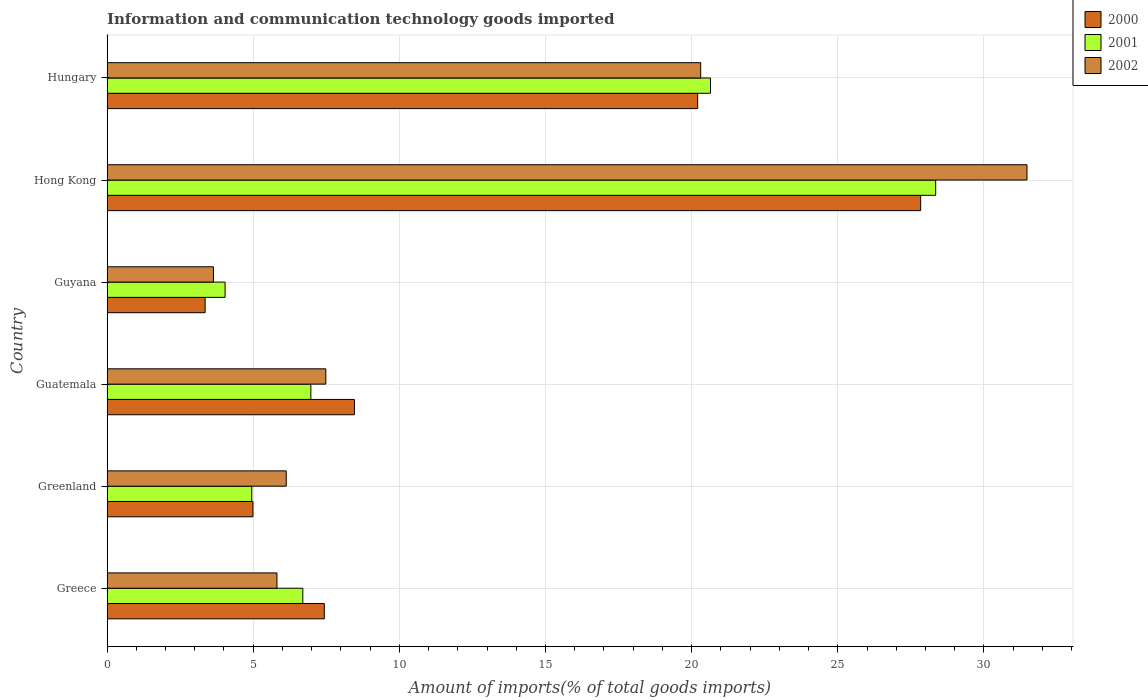How many different coloured bars are there?
Offer a terse response. 3. How many groups of bars are there?
Offer a terse response. 6. Are the number of bars per tick equal to the number of legend labels?
Make the answer very short. Yes. How many bars are there on the 4th tick from the top?
Offer a very short reply. 3. How many bars are there on the 2nd tick from the bottom?
Ensure brevity in your answer.  3. What is the label of the 2nd group of bars from the top?
Ensure brevity in your answer.  Hong Kong. What is the amount of goods imported in 2001 in Greenland?
Make the answer very short. 4.95. Across all countries, what is the maximum amount of goods imported in 2001?
Your answer should be very brief. 28.35. Across all countries, what is the minimum amount of goods imported in 2002?
Offer a terse response. 3.64. In which country was the amount of goods imported in 2001 maximum?
Offer a terse response. Hong Kong. In which country was the amount of goods imported in 2002 minimum?
Your response must be concise. Guyana. What is the total amount of goods imported in 2001 in the graph?
Your answer should be compact. 71.66. What is the difference between the amount of goods imported in 2001 in Greenland and that in Guyana?
Give a very brief answer. 0.91. What is the difference between the amount of goods imported in 2001 in Guyana and the amount of goods imported in 2002 in Greenland?
Your response must be concise. -2.09. What is the average amount of goods imported in 2000 per country?
Give a very brief answer. 12.05. What is the difference between the amount of goods imported in 2000 and amount of goods imported in 2001 in Greenland?
Make the answer very short. 0.04. What is the ratio of the amount of goods imported in 2002 in Guatemala to that in Hong Kong?
Keep it short and to the point. 0.24. Is the amount of goods imported in 2000 in Greenland less than that in Guyana?
Give a very brief answer. No. Is the difference between the amount of goods imported in 2000 in Guatemala and Hong Kong greater than the difference between the amount of goods imported in 2001 in Guatemala and Hong Kong?
Offer a very short reply. Yes. What is the difference between the highest and the second highest amount of goods imported in 2000?
Offer a terse response. 7.63. What is the difference between the highest and the lowest amount of goods imported in 2002?
Your response must be concise. 27.83. In how many countries, is the amount of goods imported in 2002 greater than the average amount of goods imported in 2002 taken over all countries?
Your answer should be compact. 2. How many countries are there in the graph?
Give a very brief answer. 6. What is the difference between two consecutive major ticks on the X-axis?
Your response must be concise. 5. Are the values on the major ticks of X-axis written in scientific E-notation?
Offer a very short reply. No. Does the graph contain grids?
Provide a short and direct response. Yes. Where does the legend appear in the graph?
Give a very brief answer. Top right. How many legend labels are there?
Keep it short and to the point. 3. How are the legend labels stacked?
Your response must be concise. Vertical. What is the title of the graph?
Your answer should be very brief. Information and communication technology goods imported. What is the label or title of the X-axis?
Offer a very short reply. Amount of imports(% of total goods imports). What is the label or title of the Y-axis?
Offer a terse response. Country. What is the Amount of imports(% of total goods imports) in 2000 in Greece?
Offer a very short reply. 7.43. What is the Amount of imports(% of total goods imports) of 2001 in Greece?
Offer a terse response. 6.7. What is the Amount of imports(% of total goods imports) in 2002 in Greece?
Provide a succinct answer. 5.81. What is the Amount of imports(% of total goods imports) of 2000 in Greenland?
Your answer should be very brief. 4.99. What is the Amount of imports(% of total goods imports) in 2001 in Greenland?
Provide a succinct answer. 4.95. What is the Amount of imports(% of total goods imports) in 2002 in Greenland?
Your answer should be compact. 6.13. What is the Amount of imports(% of total goods imports) of 2000 in Guatemala?
Offer a terse response. 8.46. What is the Amount of imports(% of total goods imports) of 2001 in Guatemala?
Your answer should be very brief. 6.97. What is the Amount of imports(% of total goods imports) of 2002 in Guatemala?
Keep it short and to the point. 7.49. What is the Amount of imports(% of total goods imports) in 2000 in Guyana?
Your response must be concise. 3.36. What is the Amount of imports(% of total goods imports) in 2001 in Guyana?
Make the answer very short. 4.04. What is the Amount of imports(% of total goods imports) in 2002 in Guyana?
Give a very brief answer. 3.64. What is the Amount of imports(% of total goods imports) of 2000 in Hong Kong?
Give a very brief answer. 27.84. What is the Amount of imports(% of total goods imports) in 2001 in Hong Kong?
Your answer should be compact. 28.35. What is the Amount of imports(% of total goods imports) of 2002 in Hong Kong?
Your answer should be compact. 31.47. What is the Amount of imports(% of total goods imports) of 2000 in Hungary?
Keep it short and to the point. 20.21. What is the Amount of imports(% of total goods imports) in 2001 in Hungary?
Offer a very short reply. 20.65. What is the Amount of imports(% of total goods imports) in 2002 in Hungary?
Offer a very short reply. 20.31. Across all countries, what is the maximum Amount of imports(% of total goods imports) in 2000?
Ensure brevity in your answer.  27.84. Across all countries, what is the maximum Amount of imports(% of total goods imports) of 2001?
Offer a terse response. 28.35. Across all countries, what is the maximum Amount of imports(% of total goods imports) in 2002?
Provide a short and direct response. 31.47. Across all countries, what is the minimum Amount of imports(% of total goods imports) of 2000?
Provide a succinct answer. 3.36. Across all countries, what is the minimum Amount of imports(% of total goods imports) of 2001?
Offer a terse response. 4.04. Across all countries, what is the minimum Amount of imports(% of total goods imports) of 2002?
Provide a succinct answer. 3.64. What is the total Amount of imports(% of total goods imports) of 2000 in the graph?
Provide a succinct answer. 72.29. What is the total Amount of imports(% of total goods imports) of 2001 in the graph?
Offer a terse response. 71.66. What is the total Amount of imports(% of total goods imports) of 2002 in the graph?
Your response must be concise. 74.85. What is the difference between the Amount of imports(% of total goods imports) of 2000 in Greece and that in Greenland?
Offer a very short reply. 2.44. What is the difference between the Amount of imports(% of total goods imports) of 2001 in Greece and that in Greenland?
Keep it short and to the point. 1.75. What is the difference between the Amount of imports(% of total goods imports) of 2002 in Greece and that in Greenland?
Provide a short and direct response. -0.32. What is the difference between the Amount of imports(% of total goods imports) of 2000 in Greece and that in Guatemala?
Your answer should be very brief. -1.03. What is the difference between the Amount of imports(% of total goods imports) of 2001 in Greece and that in Guatemala?
Your response must be concise. -0.28. What is the difference between the Amount of imports(% of total goods imports) of 2002 in Greece and that in Guatemala?
Ensure brevity in your answer.  -1.67. What is the difference between the Amount of imports(% of total goods imports) of 2000 in Greece and that in Guyana?
Ensure brevity in your answer.  4.08. What is the difference between the Amount of imports(% of total goods imports) in 2001 in Greece and that in Guyana?
Offer a terse response. 2.66. What is the difference between the Amount of imports(% of total goods imports) in 2002 in Greece and that in Guyana?
Give a very brief answer. 2.17. What is the difference between the Amount of imports(% of total goods imports) in 2000 in Greece and that in Hong Kong?
Offer a very short reply. -20.4. What is the difference between the Amount of imports(% of total goods imports) of 2001 in Greece and that in Hong Kong?
Your answer should be very brief. -21.65. What is the difference between the Amount of imports(% of total goods imports) of 2002 in Greece and that in Hong Kong?
Provide a short and direct response. -25.66. What is the difference between the Amount of imports(% of total goods imports) of 2000 in Greece and that in Hungary?
Your answer should be very brief. -12.77. What is the difference between the Amount of imports(% of total goods imports) of 2001 in Greece and that in Hungary?
Keep it short and to the point. -13.95. What is the difference between the Amount of imports(% of total goods imports) of 2002 in Greece and that in Hungary?
Provide a succinct answer. -14.5. What is the difference between the Amount of imports(% of total goods imports) in 2000 in Greenland and that in Guatemala?
Provide a succinct answer. -3.47. What is the difference between the Amount of imports(% of total goods imports) in 2001 in Greenland and that in Guatemala?
Provide a short and direct response. -2.02. What is the difference between the Amount of imports(% of total goods imports) in 2002 in Greenland and that in Guatemala?
Ensure brevity in your answer.  -1.35. What is the difference between the Amount of imports(% of total goods imports) of 2000 in Greenland and that in Guyana?
Keep it short and to the point. 1.64. What is the difference between the Amount of imports(% of total goods imports) of 2001 in Greenland and that in Guyana?
Make the answer very short. 0.91. What is the difference between the Amount of imports(% of total goods imports) in 2002 in Greenland and that in Guyana?
Your answer should be very brief. 2.49. What is the difference between the Amount of imports(% of total goods imports) of 2000 in Greenland and that in Hong Kong?
Offer a terse response. -22.84. What is the difference between the Amount of imports(% of total goods imports) in 2001 in Greenland and that in Hong Kong?
Offer a terse response. -23.4. What is the difference between the Amount of imports(% of total goods imports) of 2002 in Greenland and that in Hong Kong?
Make the answer very short. -25.34. What is the difference between the Amount of imports(% of total goods imports) in 2000 in Greenland and that in Hungary?
Provide a succinct answer. -15.21. What is the difference between the Amount of imports(% of total goods imports) in 2001 in Greenland and that in Hungary?
Provide a short and direct response. -15.69. What is the difference between the Amount of imports(% of total goods imports) in 2002 in Greenland and that in Hungary?
Offer a terse response. -14.18. What is the difference between the Amount of imports(% of total goods imports) in 2000 in Guatemala and that in Guyana?
Your answer should be very brief. 5.11. What is the difference between the Amount of imports(% of total goods imports) of 2001 in Guatemala and that in Guyana?
Offer a terse response. 2.93. What is the difference between the Amount of imports(% of total goods imports) in 2002 in Guatemala and that in Guyana?
Your answer should be compact. 3.84. What is the difference between the Amount of imports(% of total goods imports) in 2000 in Guatemala and that in Hong Kong?
Provide a succinct answer. -19.37. What is the difference between the Amount of imports(% of total goods imports) in 2001 in Guatemala and that in Hong Kong?
Keep it short and to the point. -21.37. What is the difference between the Amount of imports(% of total goods imports) in 2002 in Guatemala and that in Hong Kong?
Your answer should be very brief. -23.99. What is the difference between the Amount of imports(% of total goods imports) in 2000 in Guatemala and that in Hungary?
Your response must be concise. -11.74. What is the difference between the Amount of imports(% of total goods imports) of 2001 in Guatemala and that in Hungary?
Give a very brief answer. -13.67. What is the difference between the Amount of imports(% of total goods imports) in 2002 in Guatemala and that in Hungary?
Your answer should be very brief. -12.82. What is the difference between the Amount of imports(% of total goods imports) in 2000 in Guyana and that in Hong Kong?
Give a very brief answer. -24.48. What is the difference between the Amount of imports(% of total goods imports) in 2001 in Guyana and that in Hong Kong?
Make the answer very short. -24.31. What is the difference between the Amount of imports(% of total goods imports) of 2002 in Guyana and that in Hong Kong?
Provide a succinct answer. -27.83. What is the difference between the Amount of imports(% of total goods imports) of 2000 in Guyana and that in Hungary?
Your answer should be very brief. -16.85. What is the difference between the Amount of imports(% of total goods imports) in 2001 in Guyana and that in Hungary?
Provide a short and direct response. -16.61. What is the difference between the Amount of imports(% of total goods imports) of 2002 in Guyana and that in Hungary?
Keep it short and to the point. -16.67. What is the difference between the Amount of imports(% of total goods imports) of 2000 in Hong Kong and that in Hungary?
Ensure brevity in your answer.  7.63. What is the difference between the Amount of imports(% of total goods imports) of 2001 in Hong Kong and that in Hungary?
Your answer should be compact. 7.7. What is the difference between the Amount of imports(% of total goods imports) of 2002 in Hong Kong and that in Hungary?
Provide a succinct answer. 11.16. What is the difference between the Amount of imports(% of total goods imports) in 2000 in Greece and the Amount of imports(% of total goods imports) in 2001 in Greenland?
Provide a succinct answer. 2.48. What is the difference between the Amount of imports(% of total goods imports) of 2000 in Greece and the Amount of imports(% of total goods imports) of 2002 in Greenland?
Keep it short and to the point. 1.3. What is the difference between the Amount of imports(% of total goods imports) of 2001 in Greece and the Amount of imports(% of total goods imports) of 2002 in Greenland?
Your response must be concise. 0.57. What is the difference between the Amount of imports(% of total goods imports) of 2000 in Greece and the Amount of imports(% of total goods imports) of 2001 in Guatemala?
Keep it short and to the point. 0.46. What is the difference between the Amount of imports(% of total goods imports) in 2000 in Greece and the Amount of imports(% of total goods imports) in 2002 in Guatemala?
Keep it short and to the point. -0.05. What is the difference between the Amount of imports(% of total goods imports) of 2001 in Greece and the Amount of imports(% of total goods imports) of 2002 in Guatemala?
Provide a short and direct response. -0.79. What is the difference between the Amount of imports(% of total goods imports) in 2000 in Greece and the Amount of imports(% of total goods imports) in 2001 in Guyana?
Provide a short and direct response. 3.39. What is the difference between the Amount of imports(% of total goods imports) of 2000 in Greece and the Amount of imports(% of total goods imports) of 2002 in Guyana?
Provide a succinct answer. 3.79. What is the difference between the Amount of imports(% of total goods imports) in 2001 in Greece and the Amount of imports(% of total goods imports) in 2002 in Guyana?
Ensure brevity in your answer.  3.06. What is the difference between the Amount of imports(% of total goods imports) of 2000 in Greece and the Amount of imports(% of total goods imports) of 2001 in Hong Kong?
Provide a short and direct response. -20.91. What is the difference between the Amount of imports(% of total goods imports) of 2000 in Greece and the Amount of imports(% of total goods imports) of 2002 in Hong Kong?
Give a very brief answer. -24.04. What is the difference between the Amount of imports(% of total goods imports) in 2001 in Greece and the Amount of imports(% of total goods imports) in 2002 in Hong Kong?
Your response must be concise. -24.77. What is the difference between the Amount of imports(% of total goods imports) of 2000 in Greece and the Amount of imports(% of total goods imports) of 2001 in Hungary?
Your response must be concise. -13.21. What is the difference between the Amount of imports(% of total goods imports) in 2000 in Greece and the Amount of imports(% of total goods imports) in 2002 in Hungary?
Provide a succinct answer. -12.88. What is the difference between the Amount of imports(% of total goods imports) in 2001 in Greece and the Amount of imports(% of total goods imports) in 2002 in Hungary?
Your answer should be very brief. -13.61. What is the difference between the Amount of imports(% of total goods imports) in 2000 in Greenland and the Amount of imports(% of total goods imports) in 2001 in Guatemala?
Provide a succinct answer. -1.98. What is the difference between the Amount of imports(% of total goods imports) in 2000 in Greenland and the Amount of imports(% of total goods imports) in 2002 in Guatemala?
Provide a short and direct response. -2.49. What is the difference between the Amount of imports(% of total goods imports) of 2001 in Greenland and the Amount of imports(% of total goods imports) of 2002 in Guatemala?
Your response must be concise. -2.53. What is the difference between the Amount of imports(% of total goods imports) in 2000 in Greenland and the Amount of imports(% of total goods imports) in 2001 in Guyana?
Provide a succinct answer. 0.95. What is the difference between the Amount of imports(% of total goods imports) of 2000 in Greenland and the Amount of imports(% of total goods imports) of 2002 in Guyana?
Your response must be concise. 1.35. What is the difference between the Amount of imports(% of total goods imports) of 2001 in Greenland and the Amount of imports(% of total goods imports) of 2002 in Guyana?
Your response must be concise. 1.31. What is the difference between the Amount of imports(% of total goods imports) in 2000 in Greenland and the Amount of imports(% of total goods imports) in 2001 in Hong Kong?
Your response must be concise. -23.36. What is the difference between the Amount of imports(% of total goods imports) in 2000 in Greenland and the Amount of imports(% of total goods imports) in 2002 in Hong Kong?
Your answer should be compact. -26.48. What is the difference between the Amount of imports(% of total goods imports) of 2001 in Greenland and the Amount of imports(% of total goods imports) of 2002 in Hong Kong?
Ensure brevity in your answer.  -26.52. What is the difference between the Amount of imports(% of total goods imports) in 2000 in Greenland and the Amount of imports(% of total goods imports) in 2001 in Hungary?
Make the answer very short. -15.65. What is the difference between the Amount of imports(% of total goods imports) in 2000 in Greenland and the Amount of imports(% of total goods imports) in 2002 in Hungary?
Your response must be concise. -15.32. What is the difference between the Amount of imports(% of total goods imports) of 2001 in Greenland and the Amount of imports(% of total goods imports) of 2002 in Hungary?
Your response must be concise. -15.36. What is the difference between the Amount of imports(% of total goods imports) of 2000 in Guatemala and the Amount of imports(% of total goods imports) of 2001 in Guyana?
Give a very brief answer. 4.42. What is the difference between the Amount of imports(% of total goods imports) in 2000 in Guatemala and the Amount of imports(% of total goods imports) in 2002 in Guyana?
Ensure brevity in your answer.  4.82. What is the difference between the Amount of imports(% of total goods imports) in 2001 in Guatemala and the Amount of imports(% of total goods imports) in 2002 in Guyana?
Ensure brevity in your answer.  3.33. What is the difference between the Amount of imports(% of total goods imports) in 2000 in Guatemala and the Amount of imports(% of total goods imports) in 2001 in Hong Kong?
Offer a terse response. -19.88. What is the difference between the Amount of imports(% of total goods imports) in 2000 in Guatemala and the Amount of imports(% of total goods imports) in 2002 in Hong Kong?
Give a very brief answer. -23.01. What is the difference between the Amount of imports(% of total goods imports) of 2001 in Guatemala and the Amount of imports(% of total goods imports) of 2002 in Hong Kong?
Ensure brevity in your answer.  -24.5. What is the difference between the Amount of imports(% of total goods imports) in 2000 in Guatemala and the Amount of imports(% of total goods imports) in 2001 in Hungary?
Give a very brief answer. -12.18. What is the difference between the Amount of imports(% of total goods imports) in 2000 in Guatemala and the Amount of imports(% of total goods imports) in 2002 in Hungary?
Ensure brevity in your answer.  -11.85. What is the difference between the Amount of imports(% of total goods imports) of 2001 in Guatemala and the Amount of imports(% of total goods imports) of 2002 in Hungary?
Offer a very short reply. -13.34. What is the difference between the Amount of imports(% of total goods imports) in 2000 in Guyana and the Amount of imports(% of total goods imports) in 2001 in Hong Kong?
Give a very brief answer. -24.99. What is the difference between the Amount of imports(% of total goods imports) in 2000 in Guyana and the Amount of imports(% of total goods imports) in 2002 in Hong Kong?
Give a very brief answer. -28.12. What is the difference between the Amount of imports(% of total goods imports) in 2001 in Guyana and the Amount of imports(% of total goods imports) in 2002 in Hong Kong?
Your answer should be compact. -27.43. What is the difference between the Amount of imports(% of total goods imports) of 2000 in Guyana and the Amount of imports(% of total goods imports) of 2001 in Hungary?
Make the answer very short. -17.29. What is the difference between the Amount of imports(% of total goods imports) of 2000 in Guyana and the Amount of imports(% of total goods imports) of 2002 in Hungary?
Offer a very short reply. -16.95. What is the difference between the Amount of imports(% of total goods imports) in 2001 in Guyana and the Amount of imports(% of total goods imports) in 2002 in Hungary?
Offer a very short reply. -16.27. What is the difference between the Amount of imports(% of total goods imports) of 2000 in Hong Kong and the Amount of imports(% of total goods imports) of 2001 in Hungary?
Keep it short and to the point. 7.19. What is the difference between the Amount of imports(% of total goods imports) of 2000 in Hong Kong and the Amount of imports(% of total goods imports) of 2002 in Hungary?
Provide a succinct answer. 7.53. What is the difference between the Amount of imports(% of total goods imports) in 2001 in Hong Kong and the Amount of imports(% of total goods imports) in 2002 in Hungary?
Provide a succinct answer. 8.04. What is the average Amount of imports(% of total goods imports) of 2000 per country?
Offer a very short reply. 12.05. What is the average Amount of imports(% of total goods imports) in 2001 per country?
Your response must be concise. 11.94. What is the average Amount of imports(% of total goods imports) in 2002 per country?
Your response must be concise. 12.48. What is the difference between the Amount of imports(% of total goods imports) of 2000 and Amount of imports(% of total goods imports) of 2001 in Greece?
Provide a short and direct response. 0.74. What is the difference between the Amount of imports(% of total goods imports) in 2000 and Amount of imports(% of total goods imports) in 2002 in Greece?
Keep it short and to the point. 1.62. What is the difference between the Amount of imports(% of total goods imports) in 2001 and Amount of imports(% of total goods imports) in 2002 in Greece?
Provide a short and direct response. 0.88. What is the difference between the Amount of imports(% of total goods imports) in 2000 and Amount of imports(% of total goods imports) in 2001 in Greenland?
Provide a short and direct response. 0.04. What is the difference between the Amount of imports(% of total goods imports) in 2000 and Amount of imports(% of total goods imports) in 2002 in Greenland?
Your response must be concise. -1.14. What is the difference between the Amount of imports(% of total goods imports) of 2001 and Amount of imports(% of total goods imports) of 2002 in Greenland?
Ensure brevity in your answer.  -1.18. What is the difference between the Amount of imports(% of total goods imports) of 2000 and Amount of imports(% of total goods imports) of 2001 in Guatemala?
Offer a very short reply. 1.49. What is the difference between the Amount of imports(% of total goods imports) of 2000 and Amount of imports(% of total goods imports) of 2002 in Guatemala?
Give a very brief answer. 0.98. What is the difference between the Amount of imports(% of total goods imports) of 2001 and Amount of imports(% of total goods imports) of 2002 in Guatemala?
Your answer should be very brief. -0.51. What is the difference between the Amount of imports(% of total goods imports) of 2000 and Amount of imports(% of total goods imports) of 2001 in Guyana?
Your answer should be compact. -0.68. What is the difference between the Amount of imports(% of total goods imports) in 2000 and Amount of imports(% of total goods imports) in 2002 in Guyana?
Provide a short and direct response. -0.28. What is the difference between the Amount of imports(% of total goods imports) of 2001 and Amount of imports(% of total goods imports) of 2002 in Guyana?
Provide a succinct answer. 0.4. What is the difference between the Amount of imports(% of total goods imports) of 2000 and Amount of imports(% of total goods imports) of 2001 in Hong Kong?
Offer a very short reply. -0.51. What is the difference between the Amount of imports(% of total goods imports) of 2000 and Amount of imports(% of total goods imports) of 2002 in Hong Kong?
Offer a terse response. -3.64. What is the difference between the Amount of imports(% of total goods imports) in 2001 and Amount of imports(% of total goods imports) in 2002 in Hong Kong?
Provide a short and direct response. -3.12. What is the difference between the Amount of imports(% of total goods imports) in 2000 and Amount of imports(% of total goods imports) in 2001 in Hungary?
Give a very brief answer. -0.44. What is the difference between the Amount of imports(% of total goods imports) in 2000 and Amount of imports(% of total goods imports) in 2002 in Hungary?
Ensure brevity in your answer.  -0.1. What is the difference between the Amount of imports(% of total goods imports) in 2001 and Amount of imports(% of total goods imports) in 2002 in Hungary?
Provide a short and direct response. 0.34. What is the ratio of the Amount of imports(% of total goods imports) in 2000 in Greece to that in Greenland?
Offer a very short reply. 1.49. What is the ratio of the Amount of imports(% of total goods imports) in 2001 in Greece to that in Greenland?
Keep it short and to the point. 1.35. What is the ratio of the Amount of imports(% of total goods imports) of 2002 in Greece to that in Greenland?
Make the answer very short. 0.95. What is the ratio of the Amount of imports(% of total goods imports) in 2000 in Greece to that in Guatemala?
Offer a terse response. 0.88. What is the ratio of the Amount of imports(% of total goods imports) in 2001 in Greece to that in Guatemala?
Keep it short and to the point. 0.96. What is the ratio of the Amount of imports(% of total goods imports) in 2002 in Greece to that in Guatemala?
Provide a succinct answer. 0.78. What is the ratio of the Amount of imports(% of total goods imports) of 2000 in Greece to that in Guyana?
Ensure brevity in your answer.  2.21. What is the ratio of the Amount of imports(% of total goods imports) in 2001 in Greece to that in Guyana?
Your answer should be compact. 1.66. What is the ratio of the Amount of imports(% of total goods imports) in 2002 in Greece to that in Guyana?
Offer a very short reply. 1.6. What is the ratio of the Amount of imports(% of total goods imports) in 2000 in Greece to that in Hong Kong?
Keep it short and to the point. 0.27. What is the ratio of the Amount of imports(% of total goods imports) in 2001 in Greece to that in Hong Kong?
Give a very brief answer. 0.24. What is the ratio of the Amount of imports(% of total goods imports) in 2002 in Greece to that in Hong Kong?
Offer a very short reply. 0.18. What is the ratio of the Amount of imports(% of total goods imports) in 2000 in Greece to that in Hungary?
Your answer should be very brief. 0.37. What is the ratio of the Amount of imports(% of total goods imports) of 2001 in Greece to that in Hungary?
Your answer should be very brief. 0.32. What is the ratio of the Amount of imports(% of total goods imports) of 2002 in Greece to that in Hungary?
Keep it short and to the point. 0.29. What is the ratio of the Amount of imports(% of total goods imports) of 2000 in Greenland to that in Guatemala?
Your answer should be compact. 0.59. What is the ratio of the Amount of imports(% of total goods imports) of 2001 in Greenland to that in Guatemala?
Provide a short and direct response. 0.71. What is the ratio of the Amount of imports(% of total goods imports) in 2002 in Greenland to that in Guatemala?
Offer a very short reply. 0.82. What is the ratio of the Amount of imports(% of total goods imports) of 2000 in Greenland to that in Guyana?
Give a very brief answer. 1.49. What is the ratio of the Amount of imports(% of total goods imports) in 2001 in Greenland to that in Guyana?
Your answer should be compact. 1.23. What is the ratio of the Amount of imports(% of total goods imports) in 2002 in Greenland to that in Guyana?
Offer a very short reply. 1.68. What is the ratio of the Amount of imports(% of total goods imports) of 2000 in Greenland to that in Hong Kong?
Offer a very short reply. 0.18. What is the ratio of the Amount of imports(% of total goods imports) in 2001 in Greenland to that in Hong Kong?
Offer a terse response. 0.17. What is the ratio of the Amount of imports(% of total goods imports) of 2002 in Greenland to that in Hong Kong?
Offer a very short reply. 0.19. What is the ratio of the Amount of imports(% of total goods imports) in 2000 in Greenland to that in Hungary?
Your response must be concise. 0.25. What is the ratio of the Amount of imports(% of total goods imports) of 2001 in Greenland to that in Hungary?
Your response must be concise. 0.24. What is the ratio of the Amount of imports(% of total goods imports) of 2002 in Greenland to that in Hungary?
Your answer should be very brief. 0.3. What is the ratio of the Amount of imports(% of total goods imports) of 2000 in Guatemala to that in Guyana?
Keep it short and to the point. 2.52. What is the ratio of the Amount of imports(% of total goods imports) in 2001 in Guatemala to that in Guyana?
Your response must be concise. 1.73. What is the ratio of the Amount of imports(% of total goods imports) of 2002 in Guatemala to that in Guyana?
Offer a terse response. 2.06. What is the ratio of the Amount of imports(% of total goods imports) in 2000 in Guatemala to that in Hong Kong?
Your answer should be very brief. 0.3. What is the ratio of the Amount of imports(% of total goods imports) of 2001 in Guatemala to that in Hong Kong?
Offer a terse response. 0.25. What is the ratio of the Amount of imports(% of total goods imports) of 2002 in Guatemala to that in Hong Kong?
Keep it short and to the point. 0.24. What is the ratio of the Amount of imports(% of total goods imports) in 2000 in Guatemala to that in Hungary?
Make the answer very short. 0.42. What is the ratio of the Amount of imports(% of total goods imports) of 2001 in Guatemala to that in Hungary?
Give a very brief answer. 0.34. What is the ratio of the Amount of imports(% of total goods imports) of 2002 in Guatemala to that in Hungary?
Make the answer very short. 0.37. What is the ratio of the Amount of imports(% of total goods imports) of 2000 in Guyana to that in Hong Kong?
Make the answer very short. 0.12. What is the ratio of the Amount of imports(% of total goods imports) of 2001 in Guyana to that in Hong Kong?
Keep it short and to the point. 0.14. What is the ratio of the Amount of imports(% of total goods imports) in 2002 in Guyana to that in Hong Kong?
Make the answer very short. 0.12. What is the ratio of the Amount of imports(% of total goods imports) in 2000 in Guyana to that in Hungary?
Ensure brevity in your answer.  0.17. What is the ratio of the Amount of imports(% of total goods imports) of 2001 in Guyana to that in Hungary?
Ensure brevity in your answer.  0.2. What is the ratio of the Amount of imports(% of total goods imports) in 2002 in Guyana to that in Hungary?
Your answer should be compact. 0.18. What is the ratio of the Amount of imports(% of total goods imports) in 2000 in Hong Kong to that in Hungary?
Give a very brief answer. 1.38. What is the ratio of the Amount of imports(% of total goods imports) of 2001 in Hong Kong to that in Hungary?
Your response must be concise. 1.37. What is the ratio of the Amount of imports(% of total goods imports) of 2002 in Hong Kong to that in Hungary?
Your response must be concise. 1.55. What is the difference between the highest and the second highest Amount of imports(% of total goods imports) of 2000?
Keep it short and to the point. 7.63. What is the difference between the highest and the second highest Amount of imports(% of total goods imports) of 2001?
Keep it short and to the point. 7.7. What is the difference between the highest and the second highest Amount of imports(% of total goods imports) of 2002?
Provide a short and direct response. 11.16. What is the difference between the highest and the lowest Amount of imports(% of total goods imports) of 2000?
Provide a short and direct response. 24.48. What is the difference between the highest and the lowest Amount of imports(% of total goods imports) in 2001?
Your answer should be very brief. 24.31. What is the difference between the highest and the lowest Amount of imports(% of total goods imports) of 2002?
Your response must be concise. 27.83. 